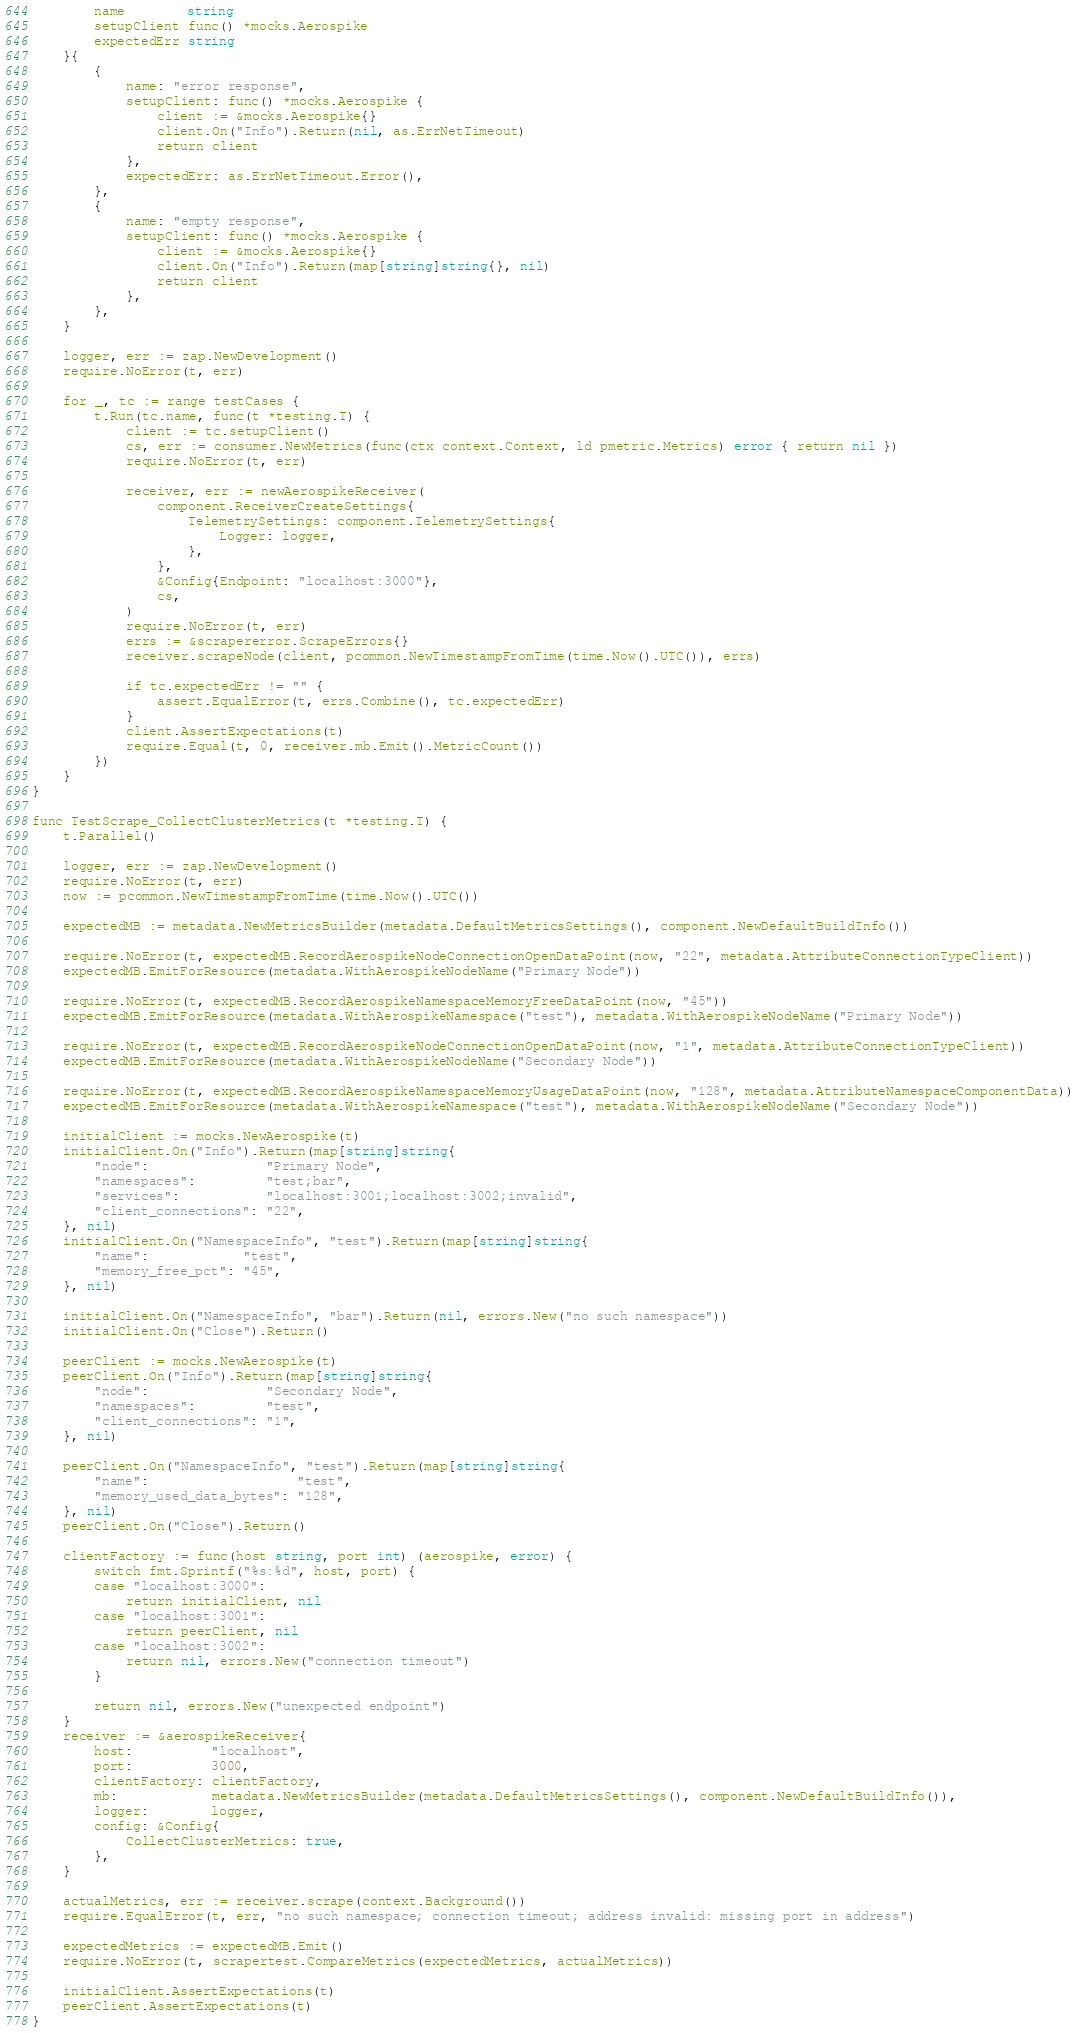Convert code to text. <code><loc_0><loc_0><loc_500><loc_500><_Go_>		name        string
		setupClient func() *mocks.Aerospike
		expectedErr string
	}{
		{
			name: "error response",
			setupClient: func() *mocks.Aerospike {
				client := &mocks.Aerospike{}
				client.On("Info").Return(nil, as.ErrNetTimeout)
				return client
			},
			expectedErr: as.ErrNetTimeout.Error(),
		},
		{
			name: "empty response",
			setupClient: func() *mocks.Aerospike {
				client := &mocks.Aerospike{}
				client.On("Info").Return(map[string]string{}, nil)
				return client
			},
		},
	}

	logger, err := zap.NewDevelopment()
	require.NoError(t, err)

	for _, tc := range testCases {
		t.Run(tc.name, func(t *testing.T) {
			client := tc.setupClient()
			cs, err := consumer.NewMetrics(func(ctx context.Context, ld pmetric.Metrics) error { return nil })
			require.NoError(t, err)

			receiver, err := newAerospikeReceiver(
				component.ReceiverCreateSettings{
					TelemetrySettings: component.TelemetrySettings{
						Logger: logger,
					},
				},
				&Config{Endpoint: "localhost:3000"},
				cs,
			)
			require.NoError(t, err)
			errs := &scrapererror.ScrapeErrors{}
			receiver.scrapeNode(client, pcommon.NewTimestampFromTime(time.Now().UTC()), errs)

			if tc.expectedErr != "" {
				assert.EqualError(t, errs.Combine(), tc.expectedErr)
			}
			client.AssertExpectations(t)
			require.Equal(t, 0, receiver.mb.Emit().MetricCount())
		})
	}
}

func TestScrape_CollectClusterMetrics(t *testing.T) {
	t.Parallel()

	logger, err := zap.NewDevelopment()
	require.NoError(t, err)
	now := pcommon.NewTimestampFromTime(time.Now().UTC())

	expectedMB := metadata.NewMetricsBuilder(metadata.DefaultMetricsSettings(), component.NewDefaultBuildInfo())

	require.NoError(t, expectedMB.RecordAerospikeNodeConnectionOpenDataPoint(now, "22", metadata.AttributeConnectionTypeClient))
	expectedMB.EmitForResource(metadata.WithAerospikeNodeName("Primary Node"))

	require.NoError(t, expectedMB.RecordAerospikeNamespaceMemoryFreeDataPoint(now, "45"))
	expectedMB.EmitForResource(metadata.WithAerospikeNamespace("test"), metadata.WithAerospikeNodeName("Primary Node"))

	require.NoError(t, expectedMB.RecordAerospikeNodeConnectionOpenDataPoint(now, "1", metadata.AttributeConnectionTypeClient))
	expectedMB.EmitForResource(metadata.WithAerospikeNodeName("Secondary Node"))

	require.NoError(t, expectedMB.RecordAerospikeNamespaceMemoryUsageDataPoint(now, "128", metadata.AttributeNamespaceComponentData))
	expectedMB.EmitForResource(metadata.WithAerospikeNamespace("test"), metadata.WithAerospikeNodeName("Secondary Node"))

	initialClient := mocks.NewAerospike(t)
	initialClient.On("Info").Return(map[string]string{
		"node":               "Primary Node",
		"namespaces":         "test;bar",
		"services":           "localhost:3001;localhost:3002;invalid",
		"client_connections": "22",
	}, nil)
	initialClient.On("NamespaceInfo", "test").Return(map[string]string{
		"name":            "test",
		"memory_free_pct": "45",
	}, nil)

	initialClient.On("NamespaceInfo", "bar").Return(nil, errors.New("no such namespace"))
	initialClient.On("Close").Return()

	peerClient := mocks.NewAerospike(t)
	peerClient.On("Info").Return(map[string]string{
		"node":               "Secondary Node",
		"namespaces":         "test",
		"client_connections": "1",
	}, nil)

	peerClient.On("NamespaceInfo", "test").Return(map[string]string{
		"name":                   "test",
		"memory_used_data_bytes": "128",
	}, nil)
	peerClient.On("Close").Return()

	clientFactory := func(host string, port int) (aerospike, error) {
		switch fmt.Sprintf("%s:%d", host, port) {
		case "localhost:3000":
			return initialClient, nil
		case "localhost:3001":
			return peerClient, nil
		case "localhost:3002":
			return nil, errors.New("connection timeout")
		}

		return nil, errors.New("unexpected endpoint")
	}
	receiver := &aerospikeReceiver{
		host:          "localhost",
		port:          3000,
		clientFactory: clientFactory,
		mb:            metadata.NewMetricsBuilder(metadata.DefaultMetricsSettings(), component.NewDefaultBuildInfo()),
		logger:        logger,
		config: &Config{
			CollectClusterMetrics: true,
		},
	}

	actualMetrics, err := receiver.scrape(context.Background())
	require.EqualError(t, err, "no such namespace; connection timeout; address invalid: missing port in address")

	expectedMetrics := expectedMB.Emit()
	require.NoError(t, scrapertest.CompareMetrics(expectedMetrics, actualMetrics))

	initialClient.AssertExpectations(t)
	peerClient.AssertExpectations(t)
}
</code> 